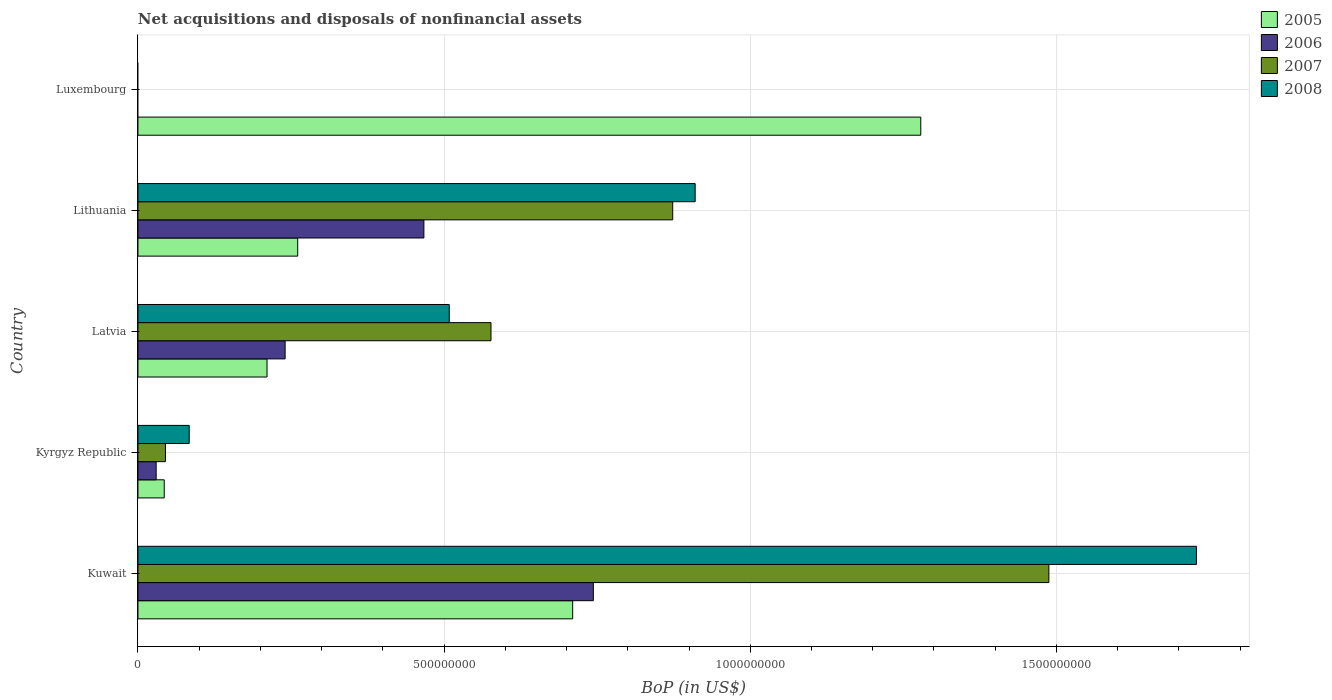Are the number of bars per tick equal to the number of legend labels?
Ensure brevity in your answer.  No. Are the number of bars on each tick of the Y-axis equal?
Offer a very short reply. No. How many bars are there on the 1st tick from the bottom?
Ensure brevity in your answer.  4. What is the label of the 5th group of bars from the top?
Give a very brief answer. Kuwait. In how many cases, is the number of bars for a given country not equal to the number of legend labels?
Offer a terse response. 1. What is the Balance of Payments in 2008 in Kuwait?
Provide a succinct answer. 1.73e+09. Across all countries, what is the maximum Balance of Payments in 2006?
Give a very brief answer. 7.44e+08. Across all countries, what is the minimum Balance of Payments in 2005?
Provide a succinct answer. 4.29e+07. In which country was the Balance of Payments in 2006 maximum?
Provide a short and direct response. Kuwait. What is the total Balance of Payments in 2006 in the graph?
Provide a short and direct response. 1.48e+09. What is the difference between the Balance of Payments in 2005 in Kuwait and that in Kyrgyz Republic?
Give a very brief answer. 6.67e+08. What is the difference between the Balance of Payments in 2006 in Luxembourg and the Balance of Payments in 2005 in Lithuania?
Provide a succinct answer. -2.61e+08. What is the average Balance of Payments in 2005 per country?
Provide a short and direct response. 5.01e+08. What is the difference between the Balance of Payments in 2008 and Balance of Payments in 2005 in Lithuania?
Offer a terse response. 6.49e+08. In how many countries, is the Balance of Payments in 2008 greater than 200000000 US$?
Offer a very short reply. 3. What is the ratio of the Balance of Payments in 2006 in Kuwait to that in Lithuania?
Make the answer very short. 1.59. Is the difference between the Balance of Payments in 2008 in Kyrgyz Republic and Lithuania greater than the difference between the Balance of Payments in 2005 in Kyrgyz Republic and Lithuania?
Keep it short and to the point. No. What is the difference between the highest and the second highest Balance of Payments in 2008?
Your answer should be compact. 8.19e+08. What is the difference between the highest and the lowest Balance of Payments in 2006?
Provide a short and direct response. 7.44e+08. In how many countries, is the Balance of Payments in 2008 greater than the average Balance of Payments in 2008 taken over all countries?
Make the answer very short. 2. Are all the bars in the graph horizontal?
Keep it short and to the point. Yes. Where does the legend appear in the graph?
Provide a short and direct response. Top right. What is the title of the graph?
Offer a very short reply. Net acquisitions and disposals of nonfinancial assets. Does "1964" appear as one of the legend labels in the graph?
Ensure brevity in your answer.  No. What is the label or title of the X-axis?
Provide a succinct answer. BoP (in US$). What is the BoP (in US$) of 2005 in Kuwait?
Give a very brief answer. 7.10e+08. What is the BoP (in US$) in 2006 in Kuwait?
Make the answer very short. 7.44e+08. What is the BoP (in US$) in 2007 in Kuwait?
Make the answer very short. 1.49e+09. What is the BoP (in US$) of 2008 in Kuwait?
Your answer should be very brief. 1.73e+09. What is the BoP (in US$) of 2005 in Kyrgyz Republic?
Give a very brief answer. 4.29e+07. What is the BoP (in US$) in 2006 in Kyrgyz Republic?
Provide a succinct answer. 2.97e+07. What is the BoP (in US$) in 2007 in Kyrgyz Republic?
Your response must be concise. 4.49e+07. What is the BoP (in US$) in 2008 in Kyrgyz Republic?
Ensure brevity in your answer.  8.37e+07. What is the BoP (in US$) of 2005 in Latvia?
Offer a terse response. 2.11e+08. What is the BoP (in US$) of 2006 in Latvia?
Make the answer very short. 2.40e+08. What is the BoP (in US$) of 2007 in Latvia?
Offer a very short reply. 5.77e+08. What is the BoP (in US$) in 2008 in Latvia?
Your response must be concise. 5.08e+08. What is the BoP (in US$) of 2005 in Lithuania?
Provide a short and direct response. 2.61e+08. What is the BoP (in US$) of 2006 in Lithuania?
Provide a succinct answer. 4.67e+08. What is the BoP (in US$) of 2007 in Lithuania?
Your answer should be compact. 8.73e+08. What is the BoP (in US$) in 2008 in Lithuania?
Keep it short and to the point. 9.10e+08. What is the BoP (in US$) in 2005 in Luxembourg?
Provide a short and direct response. 1.28e+09. What is the BoP (in US$) in 2006 in Luxembourg?
Your answer should be very brief. 0. Across all countries, what is the maximum BoP (in US$) in 2005?
Your response must be concise. 1.28e+09. Across all countries, what is the maximum BoP (in US$) of 2006?
Offer a terse response. 7.44e+08. Across all countries, what is the maximum BoP (in US$) of 2007?
Your answer should be very brief. 1.49e+09. Across all countries, what is the maximum BoP (in US$) in 2008?
Offer a very short reply. 1.73e+09. Across all countries, what is the minimum BoP (in US$) in 2005?
Give a very brief answer. 4.29e+07. Across all countries, what is the minimum BoP (in US$) in 2006?
Keep it short and to the point. 0. What is the total BoP (in US$) of 2005 in the graph?
Provide a short and direct response. 2.50e+09. What is the total BoP (in US$) in 2006 in the graph?
Give a very brief answer. 1.48e+09. What is the total BoP (in US$) of 2007 in the graph?
Keep it short and to the point. 2.98e+09. What is the total BoP (in US$) in 2008 in the graph?
Offer a terse response. 3.23e+09. What is the difference between the BoP (in US$) in 2005 in Kuwait and that in Kyrgyz Republic?
Your response must be concise. 6.67e+08. What is the difference between the BoP (in US$) in 2006 in Kuwait and that in Kyrgyz Republic?
Your response must be concise. 7.14e+08. What is the difference between the BoP (in US$) of 2007 in Kuwait and that in Kyrgyz Republic?
Your answer should be very brief. 1.44e+09. What is the difference between the BoP (in US$) in 2008 in Kuwait and that in Kyrgyz Republic?
Ensure brevity in your answer.  1.64e+09. What is the difference between the BoP (in US$) in 2005 in Kuwait and that in Latvia?
Keep it short and to the point. 4.99e+08. What is the difference between the BoP (in US$) in 2006 in Kuwait and that in Latvia?
Keep it short and to the point. 5.03e+08. What is the difference between the BoP (in US$) in 2007 in Kuwait and that in Latvia?
Your response must be concise. 9.11e+08. What is the difference between the BoP (in US$) in 2008 in Kuwait and that in Latvia?
Your answer should be compact. 1.22e+09. What is the difference between the BoP (in US$) in 2005 in Kuwait and that in Lithuania?
Ensure brevity in your answer.  4.49e+08. What is the difference between the BoP (in US$) in 2006 in Kuwait and that in Lithuania?
Offer a very short reply. 2.77e+08. What is the difference between the BoP (in US$) in 2007 in Kuwait and that in Lithuania?
Your response must be concise. 6.14e+08. What is the difference between the BoP (in US$) of 2008 in Kuwait and that in Lithuania?
Your answer should be very brief. 8.19e+08. What is the difference between the BoP (in US$) of 2005 in Kuwait and that in Luxembourg?
Give a very brief answer. -5.68e+08. What is the difference between the BoP (in US$) of 2005 in Kyrgyz Republic and that in Latvia?
Your answer should be very brief. -1.68e+08. What is the difference between the BoP (in US$) of 2006 in Kyrgyz Republic and that in Latvia?
Your answer should be compact. -2.11e+08. What is the difference between the BoP (in US$) in 2007 in Kyrgyz Republic and that in Latvia?
Give a very brief answer. -5.32e+08. What is the difference between the BoP (in US$) in 2008 in Kyrgyz Republic and that in Latvia?
Provide a short and direct response. -4.25e+08. What is the difference between the BoP (in US$) of 2005 in Kyrgyz Republic and that in Lithuania?
Your answer should be very brief. -2.18e+08. What is the difference between the BoP (in US$) in 2006 in Kyrgyz Republic and that in Lithuania?
Provide a short and direct response. -4.37e+08. What is the difference between the BoP (in US$) of 2007 in Kyrgyz Republic and that in Lithuania?
Your response must be concise. -8.28e+08. What is the difference between the BoP (in US$) of 2008 in Kyrgyz Republic and that in Lithuania?
Offer a terse response. -8.26e+08. What is the difference between the BoP (in US$) in 2005 in Kyrgyz Republic and that in Luxembourg?
Your answer should be very brief. -1.24e+09. What is the difference between the BoP (in US$) of 2005 in Latvia and that in Lithuania?
Provide a succinct answer. -5.01e+07. What is the difference between the BoP (in US$) of 2006 in Latvia and that in Lithuania?
Provide a short and direct response. -2.27e+08. What is the difference between the BoP (in US$) of 2007 in Latvia and that in Lithuania?
Ensure brevity in your answer.  -2.97e+08. What is the difference between the BoP (in US$) in 2008 in Latvia and that in Lithuania?
Make the answer very short. -4.02e+08. What is the difference between the BoP (in US$) of 2005 in Latvia and that in Luxembourg?
Provide a succinct answer. -1.07e+09. What is the difference between the BoP (in US$) of 2005 in Lithuania and that in Luxembourg?
Ensure brevity in your answer.  -1.02e+09. What is the difference between the BoP (in US$) of 2005 in Kuwait and the BoP (in US$) of 2006 in Kyrgyz Republic?
Provide a succinct answer. 6.80e+08. What is the difference between the BoP (in US$) in 2005 in Kuwait and the BoP (in US$) in 2007 in Kyrgyz Republic?
Ensure brevity in your answer.  6.65e+08. What is the difference between the BoP (in US$) of 2005 in Kuwait and the BoP (in US$) of 2008 in Kyrgyz Republic?
Keep it short and to the point. 6.26e+08. What is the difference between the BoP (in US$) of 2006 in Kuwait and the BoP (in US$) of 2007 in Kyrgyz Republic?
Make the answer very short. 6.99e+08. What is the difference between the BoP (in US$) of 2006 in Kuwait and the BoP (in US$) of 2008 in Kyrgyz Republic?
Your response must be concise. 6.60e+08. What is the difference between the BoP (in US$) in 2007 in Kuwait and the BoP (in US$) in 2008 in Kyrgyz Republic?
Offer a very short reply. 1.40e+09. What is the difference between the BoP (in US$) in 2005 in Kuwait and the BoP (in US$) in 2006 in Latvia?
Offer a very short reply. 4.70e+08. What is the difference between the BoP (in US$) of 2005 in Kuwait and the BoP (in US$) of 2007 in Latvia?
Provide a succinct answer. 1.33e+08. What is the difference between the BoP (in US$) in 2005 in Kuwait and the BoP (in US$) in 2008 in Latvia?
Your answer should be compact. 2.02e+08. What is the difference between the BoP (in US$) of 2006 in Kuwait and the BoP (in US$) of 2007 in Latvia?
Offer a very short reply. 1.67e+08. What is the difference between the BoP (in US$) in 2006 in Kuwait and the BoP (in US$) in 2008 in Latvia?
Provide a short and direct response. 2.35e+08. What is the difference between the BoP (in US$) of 2007 in Kuwait and the BoP (in US$) of 2008 in Latvia?
Ensure brevity in your answer.  9.79e+08. What is the difference between the BoP (in US$) in 2005 in Kuwait and the BoP (in US$) in 2006 in Lithuania?
Ensure brevity in your answer.  2.43e+08. What is the difference between the BoP (in US$) in 2005 in Kuwait and the BoP (in US$) in 2007 in Lithuania?
Keep it short and to the point. -1.63e+08. What is the difference between the BoP (in US$) of 2005 in Kuwait and the BoP (in US$) of 2008 in Lithuania?
Your answer should be very brief. -2.00e+08. What is the difference between the BoP (in US$) of 2006 in Kuwait and the BoP (in US$) of 2007 in Lithuania?
Offer a terse response. -1.30e+08. What is the difference between the BoP (in US$) of 2006 in Kuwait and the BoP (in US$) of 2008 in Lithuania?
Provide a succinct answer. -1.66e+08. What is the difference between the BoP (in US$) of 2007 in Kuwait and the BoP (in US$) of 2008 in Lithuania?
Ensure brevity in your answer.  5.78e+08. What is the difference between the BoP (in US$) in 2005 in Kyrgyz Republic and the BoP (in US$) in 2006 in Latvia?
Keep it short and to the point. -1.97e+08. What is the difference between the BoP (in US$) of 2005 in Kyrgyz Republic and the BoP (in US$) of 2007 in Latvia?
Offer a very short reply. -5.34e+08. What is the difference between the BoP (in US$) of 2005 in Kyrgyz Republic and the BoP (in US$) of 2008 in Latvia?
Your answer should be compact. -4.65e+08. What is the difference between the BoP (in US$) of 2006 in Kyrgyz Republic and the BoP (in US$) of 2007 in Latvia?
Your answer should be compact. -5.47e+08. What is the difference between the BoP (in US$) in 2006 in Kyrgyz Republic and the BoP (in US$) in 2008 in Latvia?
Give a very brief answer. -4.79e+08. What is the difference between the BoP (in US$) in 2007 in Kyrgyz Republic and the BoP (in US$) in 2008 in Latvia?
Your response must be concise. -4.63e+08. What is the difference between the BoP (in US$) in 2005 in Kyrgyz Republic and the BoP (in US$) in 2006 in Lithuania?
Your response must be concise. -4.24e+08. What is the difference between the BoP (in US$) in 2005 in Kyrgyz Republic and the BoP (in US$) in 2007 in Lithuania?
Provide a short and direct response. -8.30e+08. What is the difference between the BoP (in US$) of 2005 in Kyrgyz Republic and the BoP (in US$) of 2008 in Lithuania?
Ensure brevity in your answer.  -8.67e+08. What is the difference between the BoP (in US$) in 2006 in Kyrgyz Republic and the BoP (in US$) in 2007 in Lithuania?
Offer a terse response. -8.44e+08. What is the difference between the BoP (in US$) in 2006 in Kyrgyz Republic and the BoP (in US$) in 2008 in Lithuania?
Offer a very short reply. -8.80e+08. What is the difference between the BoP (in US$) in 2007 in Kyrgyz Republic and the BoP (in US$) in 2008 in Lithuania?
Ensure brevity in your answer.  -8.65e+08. What is the difference between the BoP (in US$) in 2005 in Latvia and the BoP (in US$) in 2006 in Lithuania?
Your answer should be very brief. -2.56e+08. What is the difference between the BoP (in US$) of 2005 in Latvia and the BoP (in US$) of 2007 in Lithuania?
Keep it short and to the point. -6.63e+08. What is the difference between the BoP (in US$) of 2005 in Latvia and the BoP (in US$) of 2008 in Lithuania?
Provide a succinct answer. -6.99e+08. What is the difference between the BoP (in US$) of 2006 in Latvia and the BoP (in US$) of 2007 in Lithuania?
Make the answer very short. -6.33e+08. What is the difference between the BoP (in US$) of 2006 in Latvia and the BoP (in US$) of 2008 in Lithuania?
Ensure brevity in your answer.  -6.70e+08. What is the difference between the BoP (in US$) in 2007 in Latvia and the BoP (in US$) in 2008 in Lithuania?
Your response must be concise. -3.33e+08. What is the average BoP (in US$) of 2005 per country?
Your answer should be very brief. 5.01e+08. What is the average BoP (in US$) of 2006 per country?
Provide a short and direct response. 2.96e+08. What is the average BoP (in US$) of 2007 per country?
Your answer should be compact. 5.96e+08. What is the average BoP (in US$) in 2008 per country?
Ensure brevity in your answer.  6.46e+08. What is the difference between the BoP (in US$) in 2005 and BoP (in US$) in 2006 in Kuwait?
Give a very brief answer. -3.38e+07. What is the difference between the BoP (in US$) in 2005 and BoP (in US$) in 2007 in Kuwait?
Your answer should be compact. -7.78e+08. What is the difference between the BoP (in US$) of 2005 and BoP (in US$) of 2008 in Kuwait?
Your answer should be very brief. -1.02e+09. What is the difference between the BoP (in US$) of 2006 and BoP (in US$) of 2007 in Kuwait?
Offer a terse response. -7.44e+08. What is the difference between the BoP (in US$) in 2006 and BoP (in US$) in 2008 in Kuwait?
Provide a short and direct response. -9.85e+08. What is the difference between the BoP (in US$) in 2007 and BoP (in US$) in 2008 in Kuwait?
Keep it short and to the point. -2.41e+08. What is the difference between the BoP (in US$) of 2005 and BoP (in US$) of 2006 in Kyrgyz Republic?
Make the answer very short. 1.32e+07. What is the difference between the BoP (in US$) of 2005 and BoP (in US$) of 2007 in Kyrgyz Republic?
Ensure brevity in your answer.  -2.00e+06. What is the difference between the BoP (in US$) in 2005 and BoP (in US$) in 2008 in Kyrgyz Republic?
Ensure brevity in your answer.  -4.08e+07. What is the difference between the BoP (in US$) of 2006 and BoP (in US$) of 2007 in Kyrgyz Republic?
Make the answer very short. -1.52e+07. What is the difference between the BoP (in US$) in 2006 and BoP (in US$) in 2008 in Kyrgyz Republic?
Your answer should be compact. -5.40e+07. What is the difference between the BoP (in US$) in 2007 and BoP (in US$) in 2008 in Kyrgyz Republic?
Give a very brief answer. -3.88e+07. What is the difference between the BoP (in US$) of 2005 and BoP (in US$) of 2006 in Latvia?
Keep it short and to the point. -2.96e+07. What is the difference between the BoP (in US$) of 2005 and BoP (in US$) of 2007 in Latvia?
Offer a very short reply. -3.66e+08. What is the difference between the BoP (in US$) of 2005 and BoP (in US$) of 2008 in Latvia?
Provide a succinct answer. -2.98e+08. What is the difference between the BoP (in US$) of 2006 and BoP (in US$) of 2007 in Latvia?
Offer a terse response. -3.36e+08. What is the difference between the BoP (in US$) of 2006 and BoP (in US$) of 2008 in Latvia?
Offer a terse response. -2.68e+08. What is the difference between the BoP (in US$) of 2007 and BoP (in US$) of 2008 in Latvia?
Your response must be concise. 6.82e+07. What is the difference between the BoP (in US$) in 2005 and BoP (in US$) in 2006 in Lithuania?
Your response must be concise. -2.06e+08. What is the difference between the BoP (in US$) in 2005 and BoP (in US$) in 2007 in Lithuania?
Provide a short and direct response. -6.12e+08. What is the difference between the BoP (in US$) of 2005 and BoP (in US$) of 2008 in Lithuania?
Offer a terse response. -6.49e+08. What is the difference between the BoP (in US$) of 2006 and BoP (in US$) of 2007 in Lithuania?
Your answer should be compact. -4.06e+08. What is the difference between the BoP (in US$) of 2006 and BoP (in US$) of 2008 in Lithuania?
Offer a terse response. -4.43e+08. What is the difference between the BoP (in US$) in 2007 and BoP (in US$) in 2008 in Lithuania?
Give a very brief answer. -3.67e+07. What is the ratio of the BoP (in US$) of 2005 in Kuwait to that in Kyrgyz Republic?
Your response must be concise. 16.54. What is the ratio of the BoP (in US$) in 2006 in Kuwait to that in Kyrgyz Republic?
Make the answer very short. 25.03. What is the ratio of the BoP (in US$) of 2007 in Kuwait to that in Kyrgyz Republic?
Provide a succinct answer. 33.12. What is the ratio of the BoP (in US$) of 2008 in Kuwait to that in Kyrgyz Republic?
Your answer should be compact. 20.66. What is the ratio of the BoP (in US$) in 2005 in Kuwait to that in Latvia?
Your answer should be compact. 3.37. What is the ratio of the BoP (in US$) of 2006 in Kuwait to that in Latvia?
Offer a terse response. 3.09. What is the ratio of the BoP (in US$) in 2007 in Kuwait to that in Latvia?
Your answer should be very brief. 2.58. What is the ratio of the BoP (in US$) of 2008 in Kuwait to that in Latvia?
Keep it short and to the point. 3.4. What is the ratio of the BoP (in US$) of 2005 in Kuwait to that in Lithuania?
Offer a very short reply. 2.72. What is the ratio of the BoP (in US$) in 2006 in Kuwait to that in Lithuania?
Keep it short and to the point. 1.59. What is the ratio of the BoP (in US$) in 2007 in Kuwait to that in Lithuania?
Your answer should be compact. 1.7. What is the ratio of the BoP (in US$) of 2008 in Kuwait to that in Lithuania?
Keep it short and to the point. 1.9. What is the ratio of the BoP (in US$) of 2005 in Kuwait to that in Luxembourg?
Your response must be concise. 0.56. What is the ratio of the BoP (in US$) in 2005 in Kyrgyz Republic to that in Latvia?
Offer a very short reply. 0.2. What is the ratio of the BoP (in US$) in 2006 in Kyrgyz Republic to that in Latvia?
Your response must be concise. 0.12. What is the ratio of the BoP (in US$) in 2007 in Kyrgyz Republic to that in Latvia?
Offer a terse response. 0.08. What is the ratio of the BoP (in US$) of 2008 in Kyrgyz Republic to that in Latvia?
Ensure brevity in your answer.  0.16. What is the ratio of the BoP (in US$) of 2005 in Kyrgyz Republic to that in Lithuania?
Your answer should be compact. 0.16. What is the ratio of the BoP (in US$) of 2006 in Kyrgyz Republic to that in Lithuania?
Ensure brevity in your answer.  0.06. What is the ratio of the BoP (in US$) in 2007 in Kyrgyz Republic to that in Lithuania?
Ensure brevity in your answer.  0.05. What is the ratio of the BoP (in US$) in 2008 in Kyrgyz Republic to that in Lithuania?
Offer a terse response. 0.09. What is the ratio of the BoP (in US$) in 2005 in Kyrgyz Republic to that in Luxembourg?
Provide a succinct answer. 0.03. What is the ratio of the BoP (in US$) in 2005 in Latvia to that in Lithuania?
Your response must be concise. 0.81. What is the ratio of the BoP (in US$) of 2006 in Latvia to that in Lithuania?
Give a very brief answer. 0.51. What is the ratio of the BoP (in US$) of 2007 in Latvia to that in Lithuania?
Offer a terse response. 0.66. What is the ratio of the BoP (in US$) in 2008 in Latvia to that in Lithuania?
Provide a short and direct response. 0.56. What is the ratio of the BoP (in US$) in 2005 in Latvia to that in Luxembourg?
Make the answer very short. 0.16. What is the ratio of the BoP (in US$) of 2005 in Lithuania to that in Luxembourg?
Keep it short and to the point. 0.2. What is the difference between the highest and the second highest BoP (in US$) in 2005?
Your answer should be compact. 5.68e+08. What is the difference between the highest and the second highest BoP (in US$) in 2006?
Provide a succinct answer. 2.77e+08. What is the difference between the highest and the second highest BoP (in US$) in 2007?
Keep it short and to the point. 6.14e+08. What is the difference between the highest and the second highest BoP (in US$) in 2008?
Keep it short and to the point. 8.19e+08. What is the difference between the highest and the lowest BoP (in US$) of 2005?
Your answer should be very brief. 1.24e+09. What is the difference between the highest and the lowest BoP (in US$) of 2006?
Your answer should be compact. 7.44e+08. What is the difference between the highest and the lowest BoP (in US$) of 2007?
Provide a short and direct response. 1.49e+09. What is the difference between the highest and the lowest BoP (in US$) in 2008?
Provide a succinct answer. 1.73e+09. 